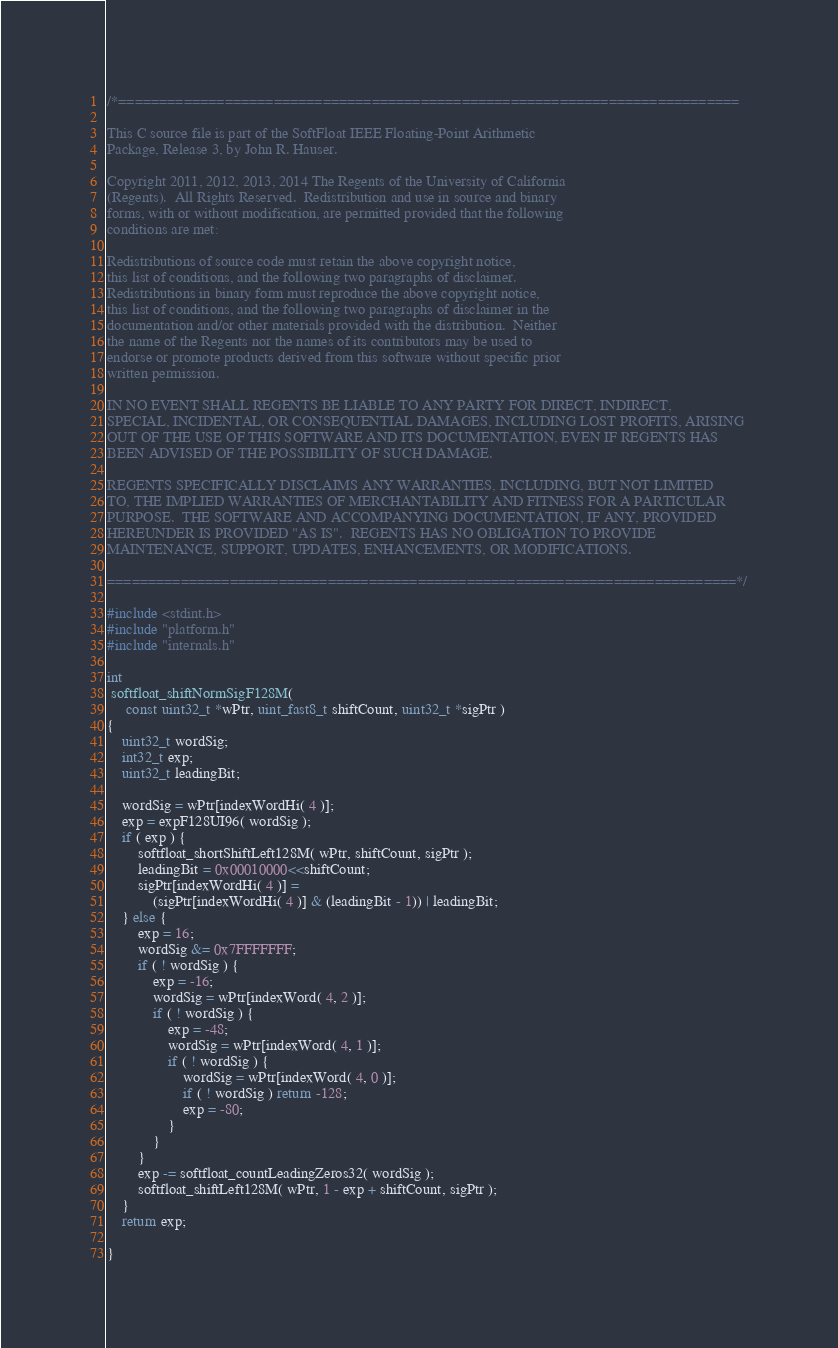<code> <loc_0><loc_0><loc_500><loc_500><_C_>
/*============================================================================

This C source file is part of the SoftFloat IEEE Floating-Point Arithmetic
Package, Release 3, by John R. Hauser.

Copyright 2011, 2012, 2013, 2014 The Regents of the University of California
(Regents).  All Rights Reserved.  Redistribution and use in source and binary
forms, with or without modification, are permitted provided that the following
conditions are met:

Redistributions of source code must retain the above copyright notice,
this list of conditions, and the following two paragraphs of disclaimer.
Redistributions in binary form must reproduce the above copyright notice,
this list of conditions, and the following two paragraphs of disclaimer in the
documentation and/or other materials provided with the distribution.  Neither
the name of the Regents nor the names of its contributors may be used to
endorse or promote products derived from this software without specific prior
written permission.

IN NO EVENT SHALL REGENTS BE LIABLE TO ANY PARTY FOR DIRECT, INDIRECT,
SPECIAL, INCIDENTAL, OR CONSEQUENTIAL DAMAGES, INCLUDING LOST PROFITS, ARISING
OUT OF THE USE OF THIS SOFTWARE AND ITS DOCUMENTATION, EVEN IF REGENTS HAS
BEEN ADVISED OF THE POSSIBILITY OF SUCH DAMAGE.

REGENTS SPECIFICALLY DISCLAIMS ANY WARRANTIES, INCLUDING, BUT NOT LIMITED
TO, THE IMPLIED WARRANTIES OF MERCHANTABILITY AND FITNESS FOR A PARTICULAR
PURPOSE.  THE SOFTWARE AND ACCOMPANYING DOCUMENTATION, IF ANY, PROVIDED
HEREUNDER IS PROVIDED "AS IS".  REGENTS HAS NO OBLIGATION TO PROVIDE
MAINTENANCE, SUPPORT, UPDATES, ENHANCEMENTS, OR MODIFICATIONS.

=============================================================================*/

#include <stdint.h>
#include "platform.h"
#include "internals.h"

int
 softfloat_shiftNormSigF128M(
     const uint32_t *wPtr, uint_fast8_t shiftCount, uint32_t *sigPtr )
{
    uint32_t wordSig;
    int32_t exp;
    uint32_t leadingBit;

    wordSig = wPtr[indexWordHi( 4 )];
    exp = expF128UI96( wordSig );
    if ( exp ) {
        softfloat_shortShiftLeft128M( wPtr, shiftCount, sigPtr );
        leadingBit = 0x00010000<<shiftCount;
        sigPtr[indexWordHi( 4 )] =
            (sigPtr[indexWordHi( 4 )] & (leadingBit - 1)) | leadingBit;
    } else {
        exp = 16;
        wordSig &= 0x7FFFFFFF;
        if ( ! wordSig ) {
            exp = -16;
            wordSig = wPtr[indexWord( 4, 2 )];
            if ( ! wordSig ) {
                exp = -48;
                wordSig = wPtr[indexWord( 4, 1 )];
                if ( ! wordSig ) {
                    wordSig = wPtr[indexWord( 4, 0 )];
                    if ( ! wordSig ) return -128;
                    exp = -80;
                }
            }
        }
        exp -= softfloat_countLeadingZeros32( wordSig );
        softfloat_shiftLeft128M( wPtr, 1 - exp + shiftCount, sigPtr );
    }
    return exp;

}

</code> 